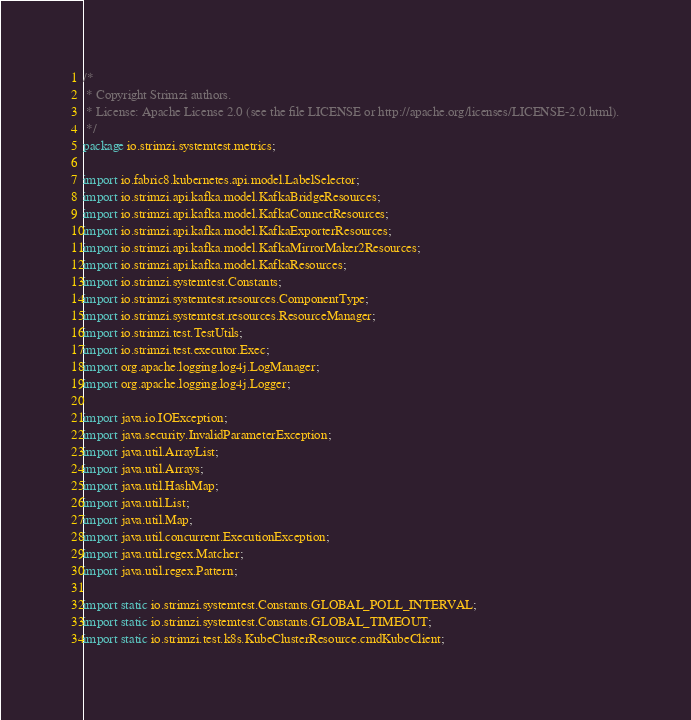Convert code to text. <code><loc_0><loc_0><loc_500><loc_500><_Java_>/*
 * Copyright Strimzi authors.
 * License: Apache License 2.0 (see the file LICENSE or http://apache.org/licenses/LICENSE-2.0.html).
 */
package io.strimzi.systemtest.metrics;

import io.fabric8.kubernetes.api.model.LabelSelector;
import io.strimzi.api.kafka.model.KafkaBridgeResources;
import io.strimzi.api.kafka.model.KafkaConnectResources;
import io.strimzi.api.kafka.model.KafkaExporterResources;
import io.strimzi.api.kafka.model.KafkaMirrorMaker2Resources;
import io.strimzi.api.kafka.model.KafkaResources;
import io.strimzi.systemtest.Constants;
import io.strimzi.systemtest.resources.ComponentType;
import io.strimzi.systemtest.resources.ResourceManager;
import io.strimzi.test.TestUtils;
import io.strimzi.test.executor.Exec;
import org.apache.logging.log4j.LogManager;
import org.apache.logging.log4j.Logger;

import java.io.IOException;
import java.security.InvalidParameterException;
import java.util.ArrayList;
import java.util.Arrays;
import java.util.HashMap;
import java.util.List;
import java.util.Map;
import java.util.concurrent.ExecutionException;
import java.util.regex.Matcher;
import java.util.regex.Pattern;

import static io.strimzi.systemtest.Constants.GLOBAL_POLL_INTERVAL;
import static io.strimzi.systemtest.Constants.GLOBAL_TIMEOUT;
import static io.strimzi.test.k8s.KubeClusterResource.cmdKubeClient;</code> 